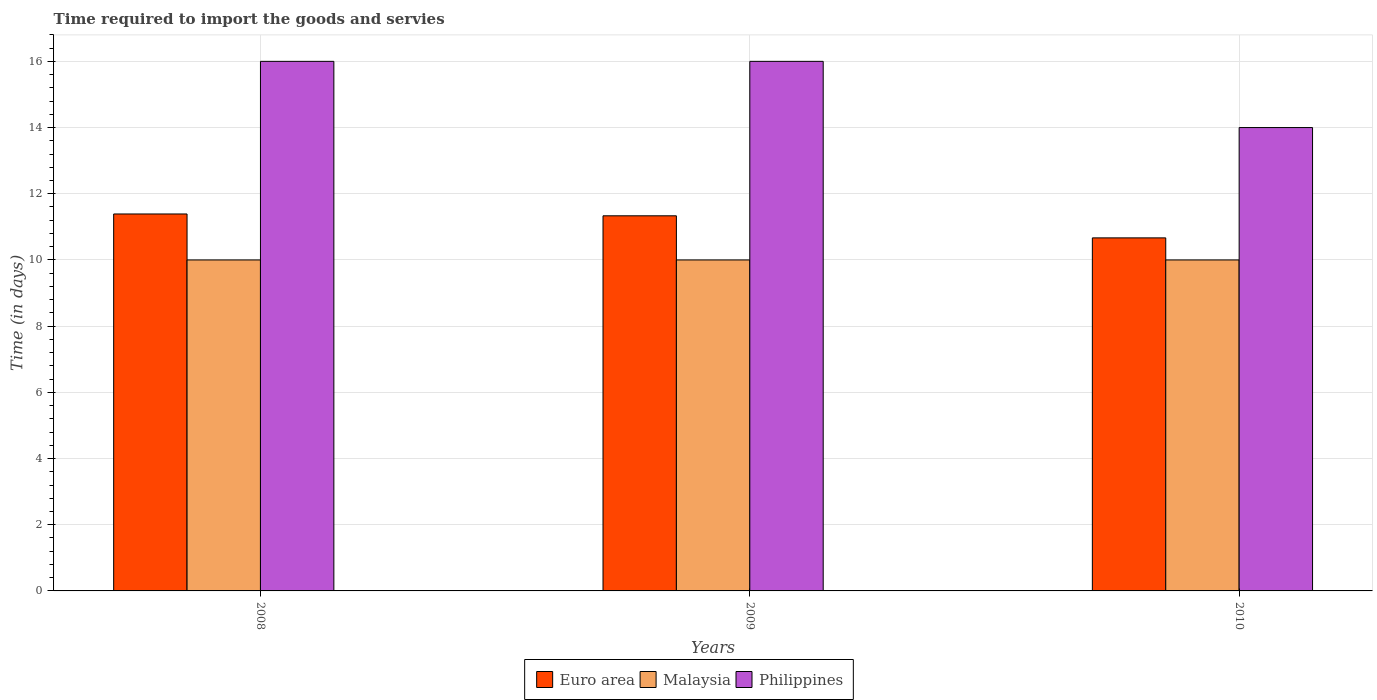How many bars are there on the 1st tick from the right?
Ensure brevity in your answer.  3. In how many cases, is the number of bars for a given year not equal to the number of legend labels?
Give a very brief answer. 0. What is the number of days required to import the goods and services in Euro area in 2008?
Keep it short and to the point. 11.39. Across all years, what is the maximum number of days required to import the goods and services in Malaysia?
Offer a very short reply. 10. Across all years, what is the minimum number of days required to import the goods and services in Malaysia?
Offer a terse response. 10. What is the total number of days required to import the goods and services in Philippines in the graph?
Ensure brevity in your answer.  46. What is the difference between the number of days required to import the goods and services in Euro area in 2008 and that in 2010?
Offer a terse response. 0.72. What is the average number of days required to import the goods and services in Malaysia per year?
Ensure brevity in your answer.  10. In the year 2008, what is the difference between the number of days required to import the goods and services in Malaysia and number of days required to import the goods and services in Philippines?
Offer a terse response. -6. What is the ratio of the number of days required to import the goods and services in Euro area in 2008 to that in 2009?
Offer a terse response. 1. Is the difference between the number of days required to import the goods and services in Malaysia in 2008 and 2010 greater than the difference between the number of days required to import the goods and services in Philippines in 2008 and 2010?
Your answer should be very brief. No. What is the difference between the highest and the second highest number of days required to import the goods and services in Euro area?
Make the answer very short. 0.06. What is the difference between the highest and the lowest number of days required to import the goods and services in Euro area?
Offer a terse response. 0.72. In how many years, is the number of days required to import the goods and services in Malaysia greater than the average number of days required to import the goods and services in Malaysia taken over all years?
Make the answer very short. 0. Is the sum of the number of days required to import the goods and services in Malaysia in 2008 and 2010 greater than the maximum number of days required to import the goods and services in Philippines across all years?
Your answer should be compact. Yes. Is it the case that in every year, the sum of the number of days required to import the goods and services in Philippines and number of days required to import the goods and services in Euro area is greater than the number of days required to import the goods and services in Malaysia?
Offer a very short reply. Yes. How many bars are there?
Ensure brevity in your answer.  9. Are all the bars in the graph horizontal?
Your answer should be compact. No. Does the graph contain grids?
Your answer should be compact. Yes. How many legend labels are there?
Offer a very short reply. 3. How are the legend labels stacked?
Ensure brevity in your answer.  Horizontal. What is the title of the graph?
Ensure brevity in your answer.  Time required to import the goods and servies. What is the label or title of the Y-axis?
Ensure brevity in your answer.  Time (in days). What is the Time (in days) in Euro area in 2008?
Provide a short and direct response. 11.39. What is the Time (in days) in Philippines in 2008?
Make the answer very short. 16. What is the Time (in days) of Euro area in 2009?
Provide a short and direct response. 11.33. What is the Time (in days) in Malaysia in 2009?
Provide a succinct answer. 10. What is the Time (in days) of Euro area in 2010?
Offer a very short reply. 10.67. Across all years, what is the maximum Time (in days) in Euro area?
Provide a short and direct response. 11.39. Across all years, what is the maximum Time (in days) in Malaysia?
Offer a very short reply. 10. Across all years, what is the minimum Time (in days) of Euro area?
Keep it short and to the point. 10.67. Across all years, what is the minimum Time (in days) of Philippines?
Offer a very short reply. 14. What is the total Time (in days) of Euro area in the graph?
Offer a very short reply. 33.39. What is the total Time (in days) of Malaysia in the graph?
Your answer should be compact. 30. What is the difference between the Time (in days) of Euro area in 2008 and that in 2009?
Give a very brief answer. 0.06. What is the difference between the Time (in days) in Malaysia in 2008 and that in 2009?
Ensure brevity in your answer.  0. What is the difference between the Time (in days) of Euro area in 2008 and that in 2010?
Your answer should be compact. 0.72. What is the difference between the Time (in days) in Malaysia in 2009 and that in 2010?
Ensure brevity in your answer.  0. What is the difference between the Time (in days) in Euro area in 2008 and the Time (in days) in Malaysia in 2009?
Give a very brief answer. 1.39. What is the difference between the Time (in days) in Euro area in 2008 and the Time (in days) in Philippines in 2009?
Your answer should be very brief. -4.61. What is the difference between the Time (in days) in Euro area in 2008 and the Time (in days) in Malaysia in 2010?
Offer a terse response. 1.39. What is the difference between the Time (in days) of Euro area in 2008 and the Time (in days) of Philippines in 2010?
Your response must be concise. -2.61. What is the difference between the Time (in days) of Malaysia in 2008 and the Time (in days) of Philippines in 2010?
Provide a succinct answer. -4. What is the difference between the Time (in days) in Euro area in 2009 and the Time (in days) in Malaysia in 2010?
Ensure brevity in your answer.  1.33. What is the difference between the Time (in days) of Euro area in 2009 and the Time (in days) of Philippines in 2010?
Make the answer very short. -2.67. What is the difference between the Time (in days) of Malaysia in 2009 and the Time (in days) of Philippines in 2010?
Ensure brevity in your answer.  -4. What is the average Time (in days) of Euro area per year?
Provide a short and direct response. 11.13. What is the average Time (in days) of Philippines per year?
Give a very brief answer. 15.33. In the year 2008, what is the difference between the Time (in days) of Euro area and Time (in days) of Malaysia?
Give a very brief answer. 1.39. In the year 2008, what is the difference between the Time (in days) in Euro area and Time (in days) in Philippines?
Make the answer very short. -4.61. In the year 2009, what is the difference between the Time (in days) in Euro area and Time (in days) in Malaysia?
Your response must be concise. 1.33. In the year 2009, what is the difference between the Time (in days) in Euro area and Time (in days) in Philippines?
Keep it short and to the point. -4.67. In the year 2009, what is the difference between the Time (in days) in Malaysia and Time (in days) in Philippines?
Offer a terse response. -6. In the year 2010, what is the difference between the Time (in days) of Euro area and Time (in days) of Malaysia?
Offer a very short reply. 0.67. In the year 2010, what is the difference between the Time (in days) of Euro area and Time (in days) of Philippines?
Make the answer very short. -3.33. What is the ratio of the Time (in days) in Malaysia in 2008 to that in 2009?
Offer a very short reply. 1. What is the ratio of the Time (in days) of Philippines in 2008 to that in 2009?
Provide a short and direct response. 1. What is the ratio of the Time (in days) in Euro area in 2008 to that in 2010?
Keep it short and to the point. 1.07. What is the ratio of the Time (in days) of Philippines in 2008 to that in 2010?
Offer a terse response. 1.14. What is the ratio of the Time (in days) of Euro area in 2009 to that in 2010?
Keep it short and to the point. 1.06. What is the ratio of the Time (in days) of Philippines in 2009 to that in 2010?
Your response must be concise. 1.14. What is the difference between the highest and the second highest Time (in days) of Euro area?
Your answer should be very brief. 0.06. What is the difference between the highest and the second highest Time (in days) in Malaysia?
Provide a succinct answer. 0. What is the difference between the highest and the lowest Time (in days) of Euro area?
Keep it short and to the point. 0.72. What is the difference between the highest and the lowest Time (in days) of Malaysia?
Your response must be concise. 0. 